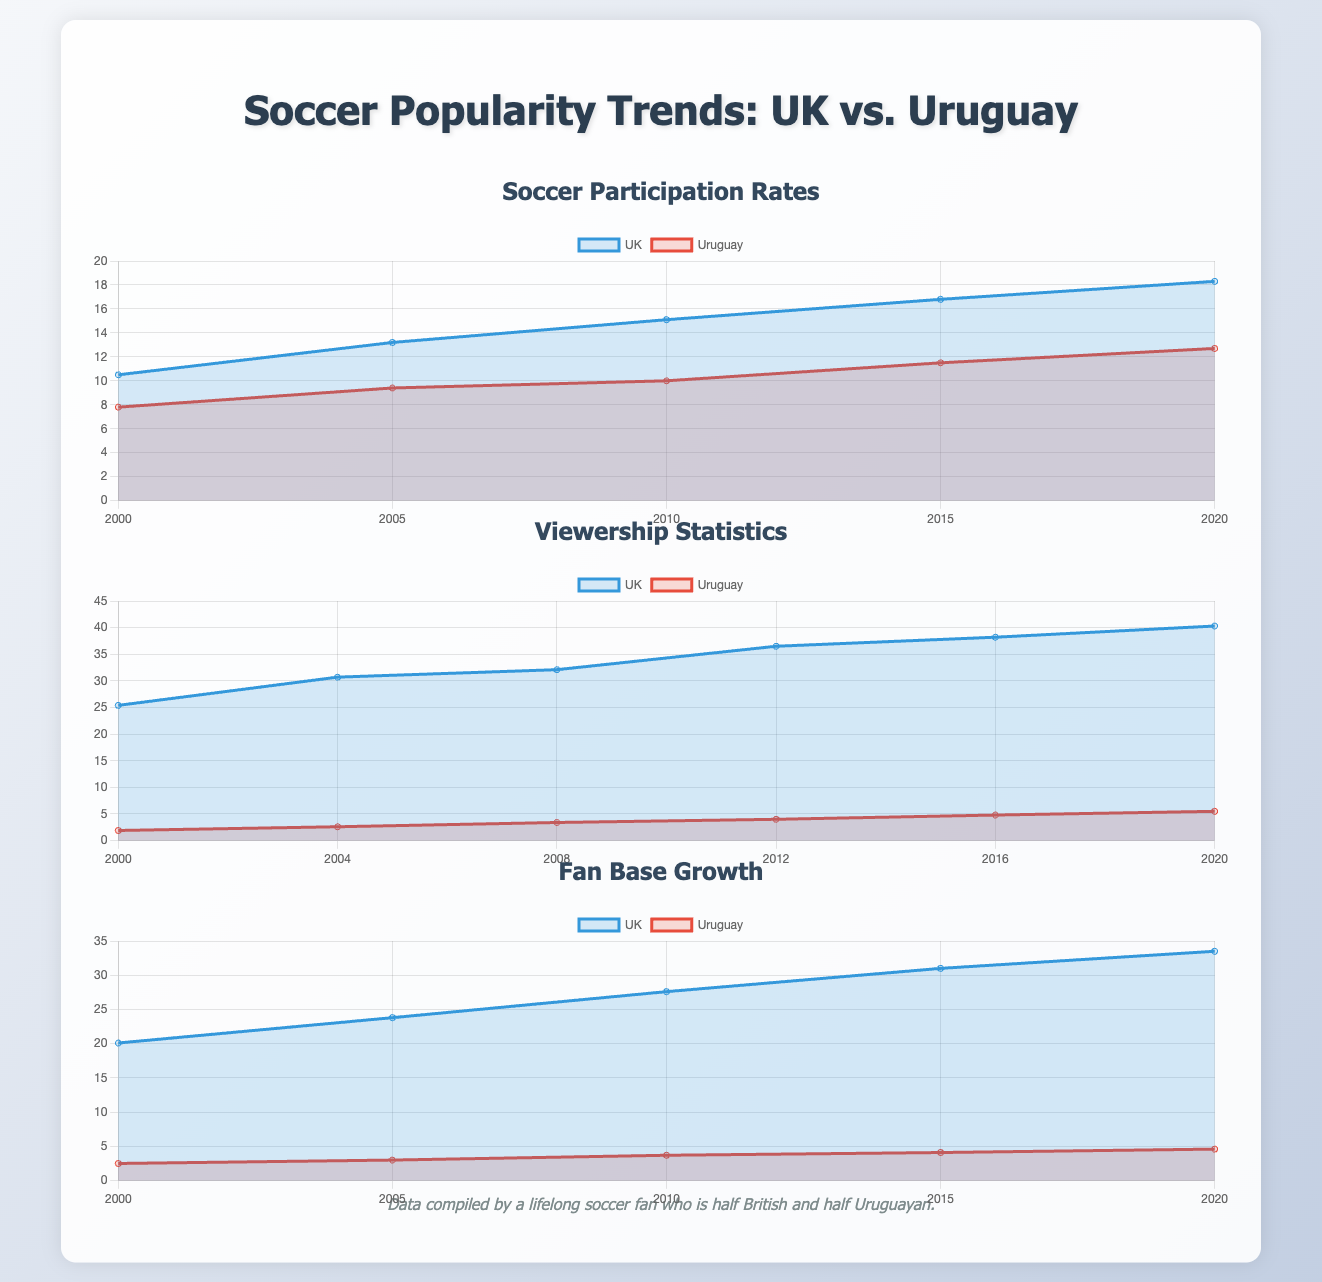What was the participation rate in the UK in 2020? The participation rate for the UK in 2020 is directly shown on the chart in the infographic.
Answer: 18.3 What year saw the highest viewership statistics in the UK? The viewership statistics for the UK is presented in a line graph; therefore, the highest point on the graph corresponds to the year that had the most viewership.
Answer: 2020 What is the fan base growth for Uruguay from 2000 to 2020? The fan base growth can be calculated by subtracting the value at 2000 from the value at 2020 in the fan base growth chart for Uruguay.
Answer: 2.1 Which country had a higher soccer participation rate in 2015? By comparing the participation rates for both countries in 2015 presented in the chart, one can determine which had a higher rate.
Answer: UK How many years are represented in the viewership statistics? Counting the number of labels in the viewership statistics chart will reveal how many years are depicted.
Answer: 6 Which dataset shows the greatest increase in participation rate over the years? Evaluating the changes in the datasets for both countries over the years will indicate which had the highest increase.
Answer: UK What was the viewership statistic for Uruguay in 2016? The viewer statistics for Uruguay in 2016 can be found directly in the data shown on the infographic.
Answer: 4.8 In which year did the fan base for the UK surpass 30 million? Analyzing the fan base growth chart will show the first point at which the UK value exceeds 30 million.
Answer: 2015 